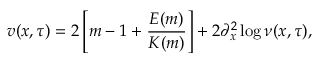<formula> <loc_0><loc_0><loc_500><loc_500>v ( x , \tau ) = 2 \left [ m - 1 + \frac { E ( m ) } { K ( m ) } \right ] + 2 \partial _ { x } ^ { 2 } \log \nu ( x , \tau ) ,</formula> 